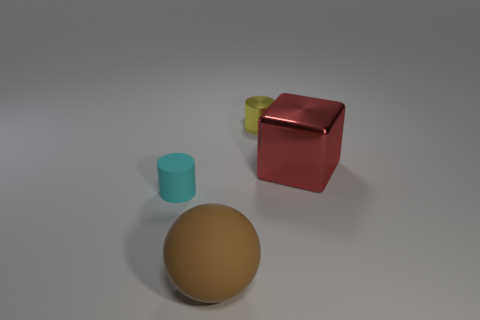Add 1 red objects. How many objects exist? 5 Subtract all cubes. How many objects are left? 3 Subtract 0 brown cylinders. How many objects are left? 4 Subtract all large things. Subtract all small cyan matte cylinders. How many objects are left? 1 Add 1 large red blocks. How many large red blocks are left? 2 Add 4 tiny rubber cylinders. How many tiny rubber cylinders exist? 5 